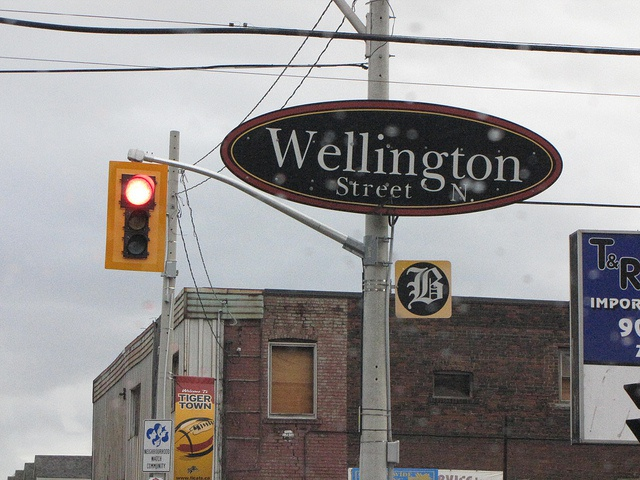Describe the objects in this image and their specific colors. I can see a traffic light in lightgray, orange, black, darkgray, and maroon tones in this image. 